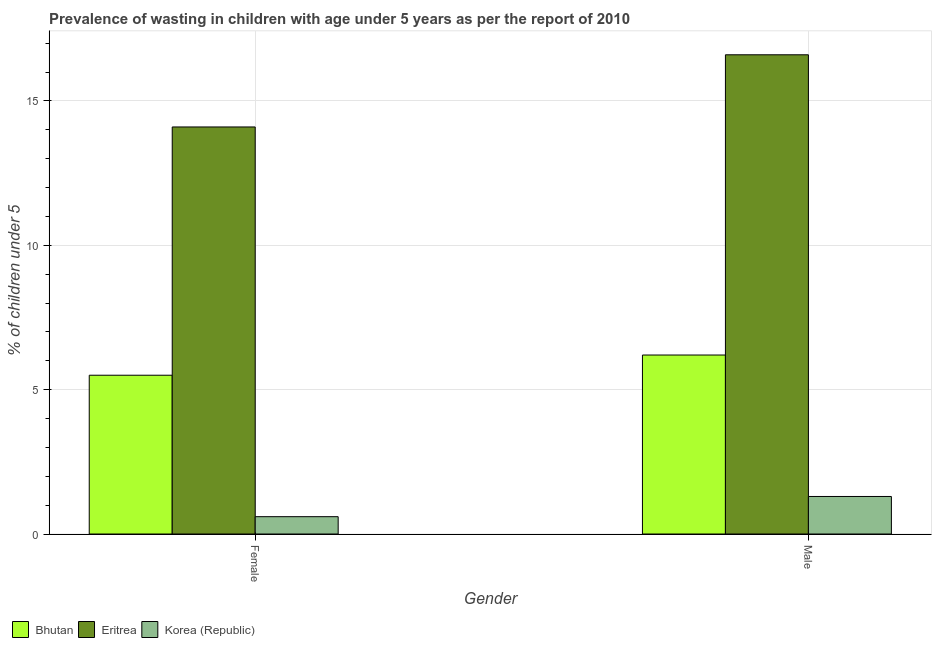Are the number of bars per tick equal to the number of legend labels?
Provide a succinct answer. Yes. Are the number of bars on each tick of the X-axis equal?
Provide a succinct answer. Yes. How many bars are there on the 2nd tick from the left?
Give a very brief answer. 3. What is the percentage of undernourished male children in Eritrea?
Give a very brief answer. 16.6. Across all countries, what is the maximum percentage of undernourished female children?
Make the answer very short. 14.1. Across all countries, what is the minimum percentage of undernourished female children?
Offer a very short reply. 0.6. In which country was the percentage of undernourished female children maximum?
Your answer should be very brief. Eritrea. In which country was the percentage of undernourished male children minimum?
Your response must be concise. Korea (Republic). What is the total percentage of undernourished female children in the graph?
Offer a very short reply. 20.2. What is the difference between the percentage of undernourished female children in Bhutan and that in Eritrea?
Keep it short and to the point. -8.6. What is the difference between the percentage of undernourished female children in Eritrea and the percentage of undernourished male children in Bhutan?
Give a very brief answer. 7.9. What is the average percentage of undernourished female children per country?
Your answer should be compact. 6.73. What is the difference between the percentage of undernourished male children and percentage of undernourished female children in Bhutan?
Offer a terse response. 0.7. In how many countries, is the percentage of undernourished female children greater than 6 %?
Provide a short and direct response. 1. What is the ratio of the percentage of undernourished male children in Eritrea to that in Bhutan?
Your answer should be compact. 2.68. What does the 2nd bar from the right in Male represents?
Keep it short and to the point. Eritrea. How many bars are there?
Keep it short and to the point. 6. Are all the bars in the graph horizontal?
Offer a terse response. No. How many countries are there in the graph?
Make the answer very short. 3. What is the difference between two consecutive major ticks on the Y-axis?
Offer a very short reply. 5. Does the graph contain grids?
Provide a succinct answer. Yes. What is the title of the graph?
Keep it short and to the point. Prevalence of wasting in children with age under 5 years as per the report of 2010. What is the label or title of the X-axis?
Provide a short and direct response. Gender. What is the label or title of the Y-axis?
Provide a succinct answer.  % of children under 5. What is the  % of children under 5 of Bhutan in Female?
Your response must be concise. 5.5. What is the  % of children under 5 of Eritrea in Female?
Offer a very short reply. 14.1. What is the  % of children under 5 of Korea (Republic) in Female?
Your answer should be very brief. 0.6. What is the  % of children under 5 in Bhutan in Male?
Give a very brief answer. 6.2. What is the  % of children under 5 of Eritrea in Male?
Provide a short and direct response. 16.6. What is the  % of children under 5 in Korea (Republic) in Male?
Your answer should be compact. 1.3. Across all Gender, what is the maximum  % of children under 5 of Bhutan?
Your response must be concise. 6.2. Across all Gender, what is the maximum  % of children under 5 in Eritrea?
Provide a succinct answer. 16.6. Across all Gender, what is the maximum  % of children under 5 of Korea (Republic)?
Make the answer very short. 1.3. Across all Gender, what is the minimum  % of children under 5 of Bhutan?
Offer a very short reply. 5.5. Across all Gender, what is the minimum  % of children under 5 in Eritrea?
Offer a very short reply. 14.1. Across all Gender, what is the minimum  % of children under 5 of Korea (Republic)?
Keep it short and to the point. 0.6. What is the total  % of children under 5 of Bhutan in the graph?
Give a very brief answer. 11.7. What is the total  % of children under 5 of Eritrea in the graph?
Provide a succinct answer. 30.7. What is the total  % of children under 5 of Korea (Republic) in the graph?
Make the answer very short. 1.9. What is the difference between the  % of children under 5 in Eritrea in Female and that in Male?
Offer a terse response. -2.5. What is the difference between the  % of children under 5 in Bhutan in Female and the  % of children under 5 in Eritrea in Male?
Keep it short and to the point. -11.1. What is the average  % of children under 5 in Bhutan per Gender?
Give a very brief answer. 5.85. What is the average  % of children under 5 of Eritrea per Gender?
Keep it short and to the point. 15.35. What is the difference between the  % of children under 5 in Bhutan and  % of children under 5 in Eritrea in Female?
Make the answer very short. -8.6. What is the difference between the  % of children under 5 in Eritrea and  % of children under 5 in Korea (Republic) in Female?
Your answer should be compact. 13.5. What is the difference between the  % of children under 5 of Bhutan and  % of children under 5 of Eritrea in Male?
Provide a succinct answer. -10.4. What is the difference between the  % of children under 5 in Bhutan and  % of children under 5 in Korea (Republic) in Male?
Your answer should be very brief. 4.9. What is the ratio of the  % of children under 5 in Bhutan in Female to that in Male?
Your response must be concise. 0.89. What is the ratio of the  % of children under 5 in Eritrea in Female to that in Male?
Your answer should be compact. 0.85. What is the ratio of the  % of children under 5 in Korea (Republic) in Female to that in Male?
Ensure brevity in your answer.  0.46. What is the difference between the highest and the second highest  % of children under 5 of Korea (Republic)?
Ensure brevity in your answer.  0.7. What is the difference between the highest and the lowest  % of children under 5 in Bhutan?
Provide a succinct answer. 0.7. What is the difference between the highest and the lowest  % of children under 5 in Eritrea?
Give a very brief answer. 2.5. 